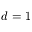Convert formula to latex. <formula><loc_0><loc_0><loc_500><loc_500>d = 1</formula> 